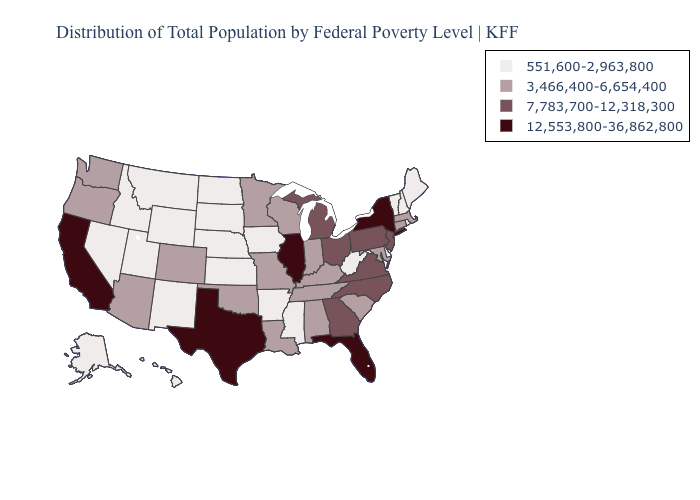Name the states that have a value in the range 7,783,700-12,318,300?
Concise answer only. Georgia, Michigan, New Jersey, North Carolina, Ohio, Pennsylvania, Virginia. What is the value of Connecticut?
Keep it brief. 3,466,400-6,654,400. Does New Mexico have the lowest value in the USA?
Keep it brief. Yes. What is the value of Kansas?
Write a very short answer. 551,600-2,963,800. Does the first symbol in the legend represent the smallest category?
Quick response, please. Yes. What is the value of Idaho?
Be succinct. 551,600-2,963,800. What is the value of Georgia?
Give a very brief answer. 7,783,700-12,318,300. Is the legend a continuous bar?
Give a very brief answer. No. How many symbols are there in the legend?
Short answer required. 4. Among the states that border Tennessee , which have the lowest value?
Concise answer only. Arkansas, Mississippi. Among the states that border Colorado , which have the lowest value?
Quick response, please. Kansas, Nebraska, New Mexico, Utah, Wyoming. Name the states that have a value in the range 551,600-2,963,800?
Be succinct. Alaska, Arkansas, Delaware, Hawaii, Idaho, Iowa, Kansas, Maine, Mississippi, Montana, Nebraska, Nevada, New Hampshire, New Mexico, North Dakota, Rhode Island, South Dakota, Utah, Vermont, West Virginia, Wyoming. What is the value of Oklahoma?
Be succinct. 3,466,400-6,654,400. Name the states that have a value in the range 551,600-2,963,800?
Answer briefly. Alaska, Arkansas, Delaware, Hawaii, Idaho, Iowa, Kansas, Maine, Mississippi, Montana, Nebraska, Nevada, New Hampshire, New Mexico, North Dakota, Rhode Island, South Dakota, Utah, Vermont, West Virginia, Wyoming. What is the value of Illinois?
Concise answer only. 12,553,800-36,862,800. 